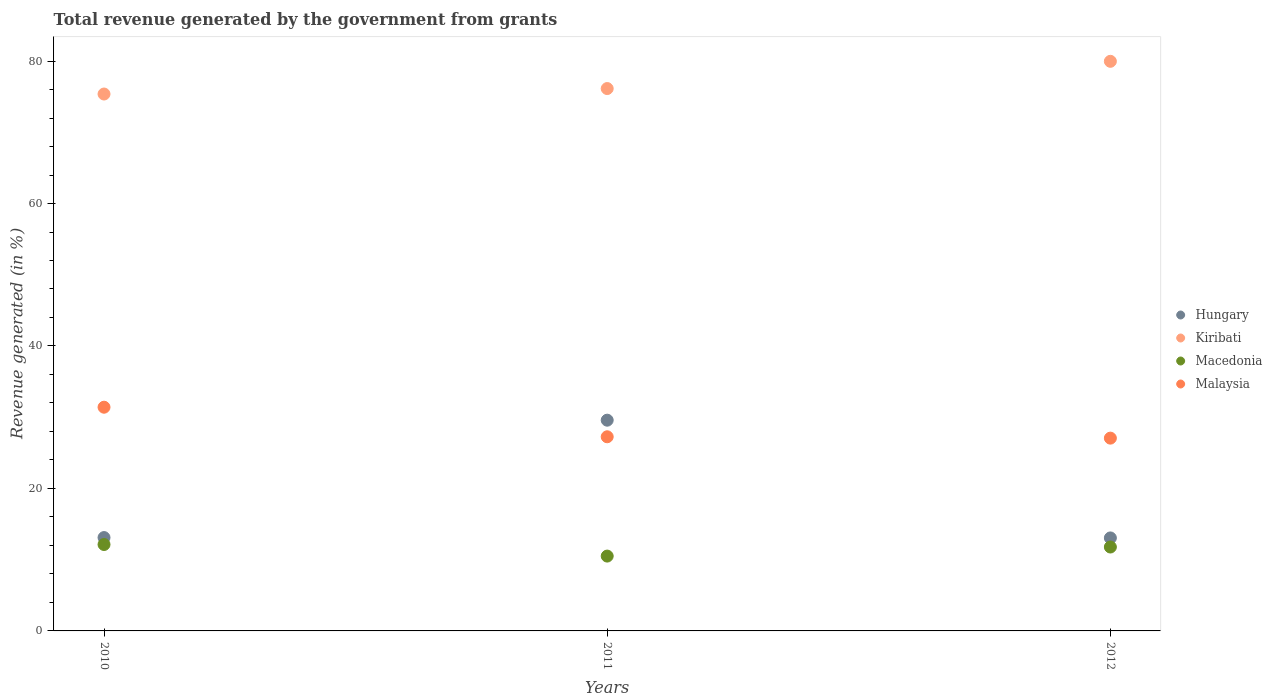How many different coloured dotlines are there?
Your response must be concise. 4. What is the total revenue generated in Malaysia in 2010?
Provide a short and direct response. 31.4. Across all years, what is the maximum total revenue generated in Kiribati?
Give a very brief answer. 79.96. Across all years, what is the minimum total revenue generated in Macedonia?
Your response must be concise. 10.51. In which year was the total revenue generated in Macedonia maximum?
Make the answer very short. 2010. In which year was the total revenue generated in Malaysia minimum?
Your response must be concise. 2012. What is the total total revenue generated in Kiribati in the graph?
Your answer should be compact. 231.47. What is the difference between the total revenue generated in Hungary in 2010 and that in 2011?
Keep it short and to the point. -16.48. What is the difference between the total revenue generated in Malaysia in 2010 and the total revenue generated in Hungary in 2012?
Give a very brief answer. 18.35. What is the average total revenue generated in Macedonia per year?
Your response must be concise. 11.47. In the year 2012, what is the difference between the total revenue generated in Hungary and total revenue generated in Macedonia?
Provide a short and direct response. 1.28. In how many years, is the total revenue generated in Malaysia greater than 60 %?
Your answer should be very brief. 0. What is the ratio of the total revenue generated in Kiribati in 2010 to that in 2011?
Your response must be concise. 0.99. Is the total revenue generated in Macedonia in 2010 less than that in 2011?
Give a very brief answer. No. Is the difference between the total revenue generated in Hungary in 2010 and 2011 greater than the difference between the total revenue generated in Macedonia in 2010 and 2011?
Your response must be concise. No. What is the difference between the highest and the second highest total revenue generated in Macedonia?
Provide a short and direct response. 0.35. What is the difference between the highest and the lowest total revenue generated in Malaysia?
Your answer should be very brief. 4.34. In how many years, is the total revenue generated in Kiribati greater than the average total revenue generated in Kiribati taken over all years?
Ensure brevity in your answer.  1. Is it the case that in every year, the sum of the total revenue generated in Hungary and total revenue generated in Kiribati  is greater than the sum of total revenue generated in Macedonia and total revenue generated in Malaysia?
Make the answer very short. Yes. Is it the case that in every year, the sum of the total revenue generated in Malaysia and total revenue generated in Kiribati  is greater than the total revenue generated in Macedonia?
Your response must be concise. Yes. Does the total revenue generated in Malaysia monotonically increase over the years?
Ensure brevity in your answer.  No. Is the total revenue generated in Kiribati strictly greater than the total revenue generated in Hungary over the years?
Offer a terse response. Yes. Is the total revenue generated in Malaysia strictly less than the total revenue generated in Kiribati over the years?
Make the answer very short. Yes. How many years are there in the graph?
Provide a short and direct response. 3. What is the difference between two consecutive major ticks on the Y-axis?
Keep it short and to the point. 20. Where does the legend appear in the graph?
Your answer should be very brief. Center right. What is the title of the graph?
Ensure brevity in your answer.  Total revenue generated by the government from grants. What is the label or title of the Y-axis?
Your answer should be very brief. Revenue generated (in %). What is the Revenue generated (in %) of Hungary in 2010?
Give a very brief answer. 13.11. What is the Revenue generated (in %) in Kiribati in 2010?
Give a very brief answer. 75.37. What is the Revenue generated (in %) in Macedonia in 2010?
Offer a very short reply. 12.13. What is the Revenue generated (in %) in Malaysia in 2010?
Your answer should be very brief. 31.4. What is the Revenue generated (in %) in Hungary in 2011?
Your answer should be compact. 29.58. What is the Revenue generated (in %) in Kiribati in 2011?
Provide a short and direct response. 76.14. What is the Revenue generated (in %) of Macedonia in 2011?
Keep it short and to the point. 10.51. What is the Revenue generated (in %) in Malaysia in 2011?
Make the answer very short. 27.25. What is the Revenue generated (in %) of Hungary in 2012?
Offer a very short reply. 13.05. What is the Revenue generated (in %) in Kiribati in 2012?
Make the answer very short. 79.96. What is the Revenue generated (in %) in Macedonia in 2012?
Your answer should be compact. 11.78. What is the Revenue generated (in %) of Malaysia in 2012?
Give a very brief answer. 27.06. Across all years, what is the maximum Revenue generated (in %) in Hungary?
Your response must be concise. 29.58. Across all years, what is the maximum Revenue generated (in %) in Kiribati?
Give a very brief answer. 79.96. Across all years, what is the maximum Revenue generated (in %) of Macedonia?
Your answer should be very brief. 12.13. Across all years, what is the maximum Revenue generated (in %) in Malaysia?
Make the answer very short. 31.4. Across all years, what is the minimum Revenue generated (in %) of Hungary?
Provide a succinct answer. 13.05. Across all years, what is the minimum Revenue generated (in %) of Kiribati?
Your answer should be compact. 75.37. Across all years, what is the minimum Revenue generated (in %) of Macedonia?
Provide a short and direct response. 10.51. Across all years, what is the minimum Revenue generated (in %) in Malaysia?
Your response must be concise. 27.06. What is the total Revenue generated (in %) in Hungary in the graph?
Ensure brevity in your answer.  55.74. What is the total Revenue generated (in %) of Kiribati in the graph?
Offer a terse response. 231.47. What is the total Revenue generated (in %) in Macedonia in the graph?
Offer a terse response. 34.42. What is the total Revenue generated (in %) in Malaysia in the graph?
Offer a very short reply. 85.72. What is the difference between the Revenue generated (in %) of Hungary in 2010 and that in 2011?
Your answer should be compact. -16.48. What is the difference between the Revenue generated (in %) of Kiribati in 2010 and that in 2011?
Offer a terse response. -0.77. What is the difference between the Revenue generated (in %) of Macedonia in 2010 and that in 2011?
Give a very brief answer. 1.63. What is the difference between the Revenue generated (in %) of Malaysia in 2010 and that in 2011?
Your answer should be very brief. 4.15. What is the difference between the Revenue generated (in %) of Hungary in 2010 and that in 2012?
Make the answer very short. 0.05. What is the difference between the Revenue generated (in %) of Kiribati in 2010 and that in 2012?
Provide a succinct answer. -4.59. What is the difference between the Revenue generated (in %) in Macedonia in 2010 and that in 2012?
Provide a short and direct response. 0.35. What is the difference between the Revenue generated (in %) of Malaysia in 2010 and that in 2012?
Give a very brief answer. 4.34. What is the difference between the Revenue generated (in %) in Hungary in 2011 and that in 2012?
Your response must be concise. 16.53. What is the difference between the Revenue generated (in %) of Kiribati in 2011 and that in 2012?
Offer a very short reply. -3.82. What is the difference between the Revenue generated (in %) in Macedonia in 2011 and that in 2012?
Keep it short and to the point. -1.27. What is the difference between the Revenue generated (in %) in Malaysia in 2011 and that in 2012?
Make the answer very short. 0.19. What is the difference between the Revenue generated (in %) in Hungary in 2010 and the Revenue generated (in %) in Kiribati in 2011?
Provide a short and direct response. -63.03. What is the difference between the Revenue generated (in %) in Hungary in 2010 and the Revenue generated (in %) in Macedonia in 2011?
Ensure brevity in your answer.  2.6. What is the difference between the Revenue generated (in %) of Hungary in 2010 and the Revenue generated (in %) of Malaysia in 2011?
Your answer should be very brief. -14.15. What is the difference between the Revenue generated (in %) in Kiribati in 2010 and the Revenue generated (in %) in Macedonia in 2011?
Your answer should be very brief. 64.86. What is the difference between the Revenue generated (in %) of Kiribati in 2010 and the Revenue generated (in %) of Malaysia in 2011?
Provide a succinct answer. 48.12. What is the difference between the Revenue generated (in %) of Macedonia in 2010 and the Revenue generated (in %) of Malaysia in 2011?
Keep it short and to the point. -15.12. What is the difference between the Revenue generated (in %) of Hungary in 2010 and the Revenue generated (in %) of Kiribati in 2012?
Keep it short and to the point. -66.86. What is the difference between the Revenue generated (in %) in Hungary in 2010 and the Revenue generated (in %) in Macedonia in 2012?
Offer a very short reply. 1.33. What is the difference between the Revenue generated (in %) of Hungary in 2010 and the Revenue generated (in %) of Malaysia in 2012?
Make the answer very short. -13.96. What is the difference between the Revenue generated (in %) of Kiribati in 2010 and the Revenue generated (in %) of Macedonia in 2012?
Provide a short and direct response. 63.59. What is the difference between the Revenue generated (in %) of Kiribati in 2010 and the Revenue generated (in %) of Malaysia in 2012?
Make the answer very short. 48.31. What is the difference between the Revenue generated (in %) in Macedonia in 2010 and the Revenue generated (in %) in Malaysia in 2012?
Provide a short and direct response. -14.93. What is the difference between the Revenue generated (in %) in Hungary in 2011 and the Revenue generated (in %) in Kiribati in 2012?
Ensure brevity in your answer.  -50.38. What is the difference between the Revenue generated (in %) in Hungary in 2011 and the Revenue generated (in %) in Macedonia in 2012?
Your answer should be very brief. 17.81. What is the difference between the Revenue generated (in %) of Hungary in 2011 and the Revenue generated (in %) of Malaysia in 2012?
Your answer should be very brief. 2.52. What is the difference between the Revenue generated (in %) of Kiribati in 2011 and the Revenue generated (in %) of Macedonia in 2012?
Your answer should be compact. 64.36. What is the difference between the Revenue generated (in %) of Kiribati in 2011 and the Revenue generated (in %) of Malaysia in 2012?
Make the answer very short. 49.07. What is the difference between the Revenue generated (in %) of Macedonia in 2011 and the Revenue generated (in %) of Malaysia in 2012?
Keep it short and to the point. -16.56. What is the average Revenue generated (in %) of Hungary per year?
Provide a short and direct response. 18.58. What is the average Revenue generated (in %) in Kiribati per year?
Your answer should be compact. 77.16. What is the average Revenue generated (in %) in Macedonia per year?
Ensure brevity in your answer.  11.47. What is the average Revenue generated (in %) in Malaysia per year?
Provide a succinct answer. 28.57. In the year 2010, what is the difference between the Revenue generated (in %) in Hungary and Revenue generated (in %) in Kiribati?
Offer a very short reply. -62.27. In the year 2010, what is the difference between the Revenue generated (in %) of Hungary and Revenue generated (in %) of Malaysia?
Offer a terse response. -18.3. In the year 2010, what is the difference between the Revenue generated (in %) in Kiribati and Revenue generated (in %) in Macedonia?
Provide a succinct answer. 63.24. In the year 2010, what is the difference between the Revenue generated (in %) of Kiribati and Revenue generated (in %) of Malaysia?
Ensure brevity in your answer.  43.97. In the year 2010, what is the difference between the Revenue generated (in %) of Macedonia and Revenue generated (in %) of Malaysia?
Provide a short and direct response. -19.27. In the year 2011, what is the difference between the Revenue generated (in %) in Hungary and Revenue generated (in %) in Kiribati?
Keep it short and to the point. -46.55. In the year 2011, what is the difference between the Revenue generated (in %) in Hungary and Revenue generated (in %) in Macedonia?
Make the answer very short. 19.08. In the year 2011, what is the difference between the Revenue generated (in %) in Hungary and Revenue generated (in %) in Malaysia?
Provide a succinct answer. 2.33. In the year 2011, what is the difference between the Revenue generated (in %) of Kiribati and Revenue generated (in %) of Macedonia?
Make the answer very short. 65.63. In the year 2011, what is the difference between the Revenue generated (in %) in Kiribati and Revenue generated (in %) in Malaysia?
Provide a short and direct response. 48.88. In the year 2011, what is the difference between the Revenue generated (in %) of Macedonia and Revenue generated (in %) of Malaysia?
Keep it short and to the point. -16.75. In the year 2012, what is the difference between the Revenue generated (in %) of Hungary and Revenue generated (in %) of Kiribati?
Make the answer very short. -66.91. In the year 2012, what is the difference between the Revenue generated (in %) of Hungary and Revenue generated (in %) of Macedonia?
Offer a terse response. 1.28. In the year 2012, what is the difference between the Revenue generated (in %) in Hungary and Revenue generated (in %) in Malaysia?
Your answer should be compact. -14.01. In the year 2012, what is the difference between the Revenue generated (in %) in Kiribati and Revenue generated (in %) in Macedonia?
Offer a very short reply. 68.19. In the year 2012, what is the difference between the Revenue generated (in %) in Kiribati and Revenue generated (in %) in Malaysia?
Provide a succinct answer. 52.9. In the year 2012, what is the difference between the Revenue generated (in %) in Macedonia and Revenue generated (in %) in Malaysia?
Offer a very short reply. -15.29. What is the ratio of the Revenue generated (in %) of Hungary in 2010 to that in 2011?
Keep it short and to the point. 0.44. What is the ratio of the Revenue generated (in %) of Kiribati in 2010 to that in 2011?
Your answer should be very brief. 0.99. What is the ratio of the Revenue generated (in %) in Macedonia in 2010 to that in 2011?
Ensure brevity in your answer.  1.15. What is the ratio of the Revenue generated (in %) of Malaysia in 2010 to that in 2011?
Your answer should be very brief. 1.15. What is the ratio of the Revenue generated (in %) in Kiribati in 2010 to that in 2012?
Make the answer very short. 0.94. What is the ratio of the Revenue generated (in %) of Malaysia in 2010 to that in 2012?
Keep it short and to the point. 1.16. What is the ratio of the Revenue generated (in %) in Hungary in 2011 to that in 2012?
Offer a terse response. 2.27. What is the ratio of the Revenue generated (in %) in Kiribati in 2011 to that in 2012?
Your response must be concise. 0.95. What is the ratio of the Revenue generated (in %) in Macedonia in 2011 to that in 2012?
Keep it short and to the point. 0.89. What is the difference between the highest and the second highest Revenue generated (in %) of Hungary?
Provide a short and direct response. 16.48. What is the difference between the highest and the second highest Revenue generated (in %) of Kiribati?
Give a very brief answer. 3.82. What is the difference between the highest and the second highest Revenue generated (in %) of Macedonia?
Ensure brevity in your answer.  0.35. What is the difference between the highest and the second highest Revenue generated (in %) of Malaysia?
Offer a terse response. 4.15. What is the difference between the highest and the lowest Revenue generated (in %) of Hungary?
Offer a very short reply. 16.53. What is the difference between the highest and the lowest Revenue generated (in %) of Kiribati?
Your answer should be compact. 4.59. What is the difference between the highest and the lowest Revenue generated (in %) in Macedonia?
Give a very brief answer. 1.63. What is the difference between the highest and the lowest Revenue generated (in %) of Malaysia?
Keep it short and to the point. 4.34. 